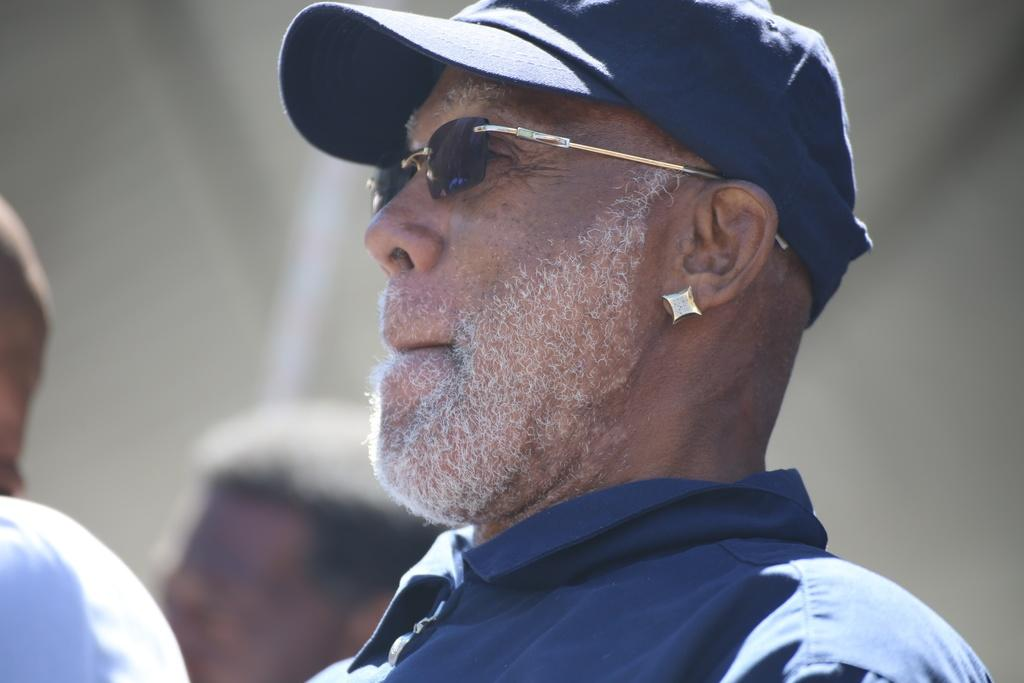What is the main subject of the image? There is a man in the image. What is the man wearing on his upper body? The man is wearing a blue shirt. What type of headwear is the man wearing? The man is wearing a cap. Can you describe the background of the image? The background of the image is blurred. What type of garden can be seen in the background of the image? There is no garden visible in the image; the background is blurred. What type of glass object is the man holding in the image? There is no glass object present in the image. 